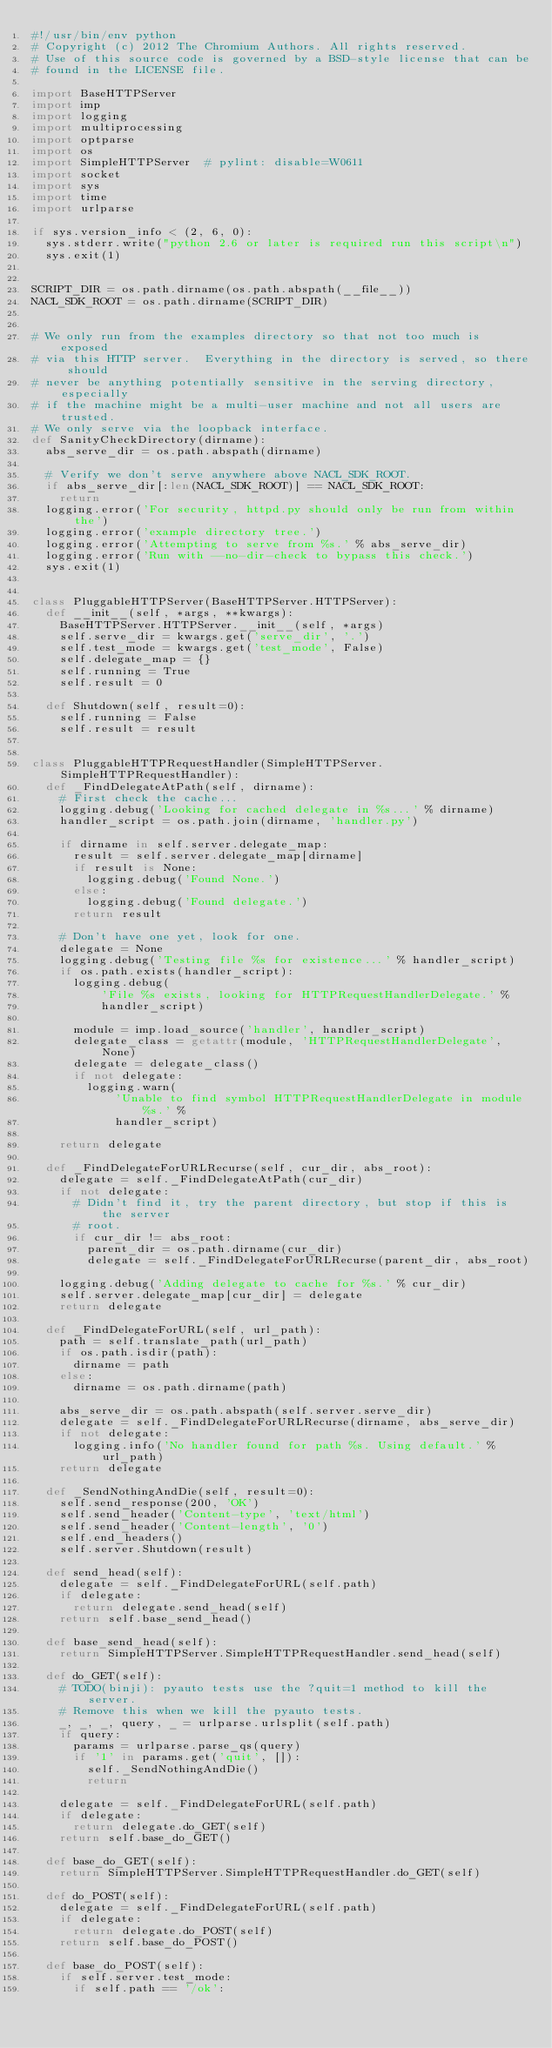<code> <loc_0><loc_0><loc_500><loc_500><_Python_>#!/usr/bin/env python
# Copyright (c) 2012 The Chromium Authors. All rights reserved.
# Use of this source code is governed by a BSD-style license that can be
# found in the LICENSE file.

import BaseHTTPServer
import imp
import logging
import multiprocessing
import optparse
import os
import SimpleHTTPServer  # pylint: disable=W0611
import socket
import sys
import time
import urlparse

if sys.version_info < (2, 6, 0):
  sys.stderr.write("python 2.6 or later is required run this script\n")
  sys.exit(1)


SCRIPT_DIR = os.path.dirname(os.path.abspath(__file__))
NACL_SDK_ROOT = os.path.dirname(SCRIPT_DIR)


# We only run from the examples directory so that not too much is exposed
# via this HTTP server.  Everything in the directory is served, so there should
# never be anything potentially sensitive in the serving directory, especially
# if the machine might be a multi-user machine and not all users are trusted.
# We only serve via the loopback interface.
def SanityCheckDirectory(dirname):
  abs_serve_dir = os.path.abspath(dirname)

  # Verify we don't serve anywhere above NACL_SDK_ROOT.
  if abs_serve_dir[:len(NACL_SDK_ROOT)] == NACL_SDK_ROOT:
    return
  logging.error('For security, httpd.py should only be run from within the')
  logging.error('example directory tree.')
  logging.error('Attempting to serve from %s.' % abs_serve_dir)
  logging.error('Run with --no-dir-check to bypass this check.')
  sys.exit(1)


class PluggableHTTPServer(BaseHTTPServer.HTTPServer):
  def __init__(self, *args, **kwargs):
    BaseHTTPServer.HTTPServer.__init__(self, *args)
    self.serve_dir = kwargs.get('serve_dir', '.')
    self.test_mode = kwargs.get('test_mode', False)
    self.delegate_map = {}
    self.running = True
    self.result = 0

  def Shutdown(self, result=0):
    self.running = False
    self.result = result


class PluggableHTTPRequestHandler(SimpleHTTPServer.SimpleHTTPRequestHandler):
  def _FindDelegateAtPath(self, dirname):
    # First check the cache...
    logging.debug('Looking for cached delegate in %s...' % dirname)
    handler_script = os.path.join(dirname, 'handler.py')

    if dirname in self.server.delegate_map:
      result = self.server.delegate_map[dirname]
      if result is None:
        logging.debug('Found None.')
      else:
        logging.debug('Found delegate.')
      return result

    # Don't have one yet, look for one.
    delegate = None
    logging.debug('Testing file %s for existence...' % handler_script)
    if os.path.exists(handler_script):
      logging.debug(
          'File %s exists, looking for HTTPRequestHandlerDelegate.' %
          handler_script)

      module = imp.load_source('handler', handler_script)
      delegate_class = getattr(module, 'HTTPRequestHandlerDelegate', None)
      delegate = delegate_class()
      if not delegate:
        logging.warn(
            'Unable to find symbol HTTPRequestHandlerDelegate in module %s.' %
            handler_script)

    return delegate

  def _FindDelegateForURLRecurse(self, cur_dir, abs_root):
    delegate = self._FindDelegateAtPath(cur_dir)
    if not delegate:
      # Didn't find it, try the parent directory, but stop if this is the server
      # root.
      if cur_dir != abs_root:
        parent_dir = os.path.dirname(cur_dir)
        delegate = self._FindDelegateForURLRecurse(parent_dir, abs_root)

    logging.debug('Adding delegate to cache for %s.' % cur_dir)
    self.server.delegate_map[cur_dir] = delegate
    return delegate

  def _FindDelegateForURL(self, url_path):
    path = self.translate_path(url_path)
    if os.path.isdir(path):
      dirname = path
    else:
      dirname = os.path.dirname(path)

    abs_serve_dir = os.path.abspath(self.server.serve_dir)
    delegate = self._FindDelegateForURLRecurse(dirname, abs_serve_dir)
    if not delegate:
      logging.info('No handler found for path %s. Using default.' % url_path)
    return delegate

  def _SendNothingAndDie(self, result=0):
    self.send_response(200, 'OK')
    self.send_header('Content-type', 'text/html')
    self.send_header('Content-length', '0')
    self.end_headers()
    self.server.Shutdown(result)

  def send_head(self):
    delegate = self._FindDelegateForURL(self.path)
    if delegate:
      return delegate.send_head(self)
    return self.base_send_head()

  def base_send_head(self):
    return SimpleHTTPServer.SimpleHTTPRequestHandler.send_head(self)

  def do_GET(self):
    # TODO(binji): pyauto tests use the ?quit=1 method to kill the server.
    # Remove this when we kill the pyauto tests.
    _, _, _, query, _ = urlparse.urlsplit(self.path)
    if query:
      params = urlparse.parse_qs(query)
      if '1' in params.get('quit', []):
        self._SendNothingAndDie()
        return

    delegate = self._FindDelegateForURL(self.path)
    if delegate:
      return delegate.do_GET(self)
    return self.base_do_GET()

  def base_do_GET(self):
    return SimpleHTTPServer.SimpleHTTPRequestHandler.do_GET(self)

  def do_POST(self):
    delegate = self._FindDelegateForURL(self.path)
    if delegate:
      return delegate.do_POST(self)
    return self.base_do_POST()

  def base_do_POST(self):
    if self.server.test_mode:
      if self.path == '/ok':</code> 